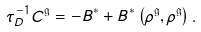<formula> <loc_0><loc_0><loc_500><loc_500>\tau _ { D } ^ { - 1 } C ^ { \mathfrak g } = - B ^ { * } + B ^ { * } \left ( \rho ^ { \mathfrak g } , \rho ^ { \mathfrak g } \right ) .</formula> 